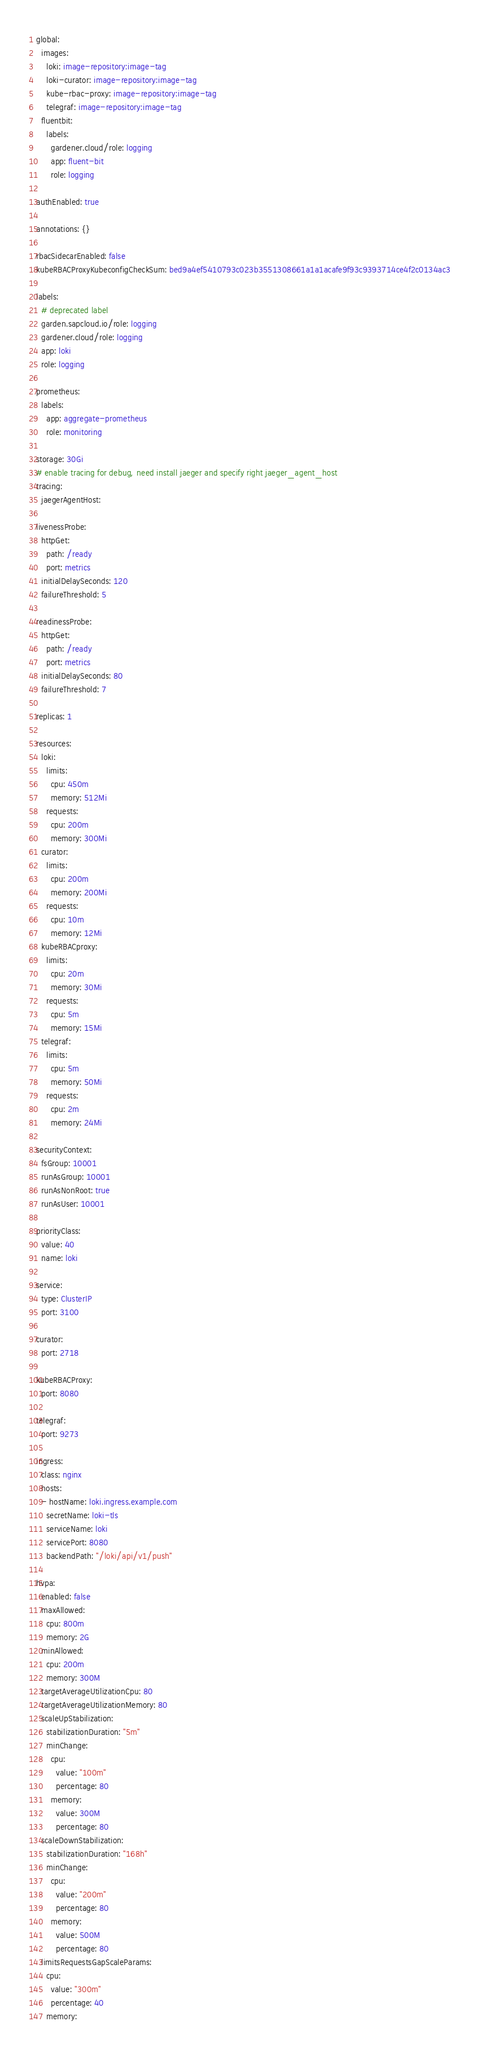Convert code to text. <code><loc_0><loc_0><loc_500><loc_500><_YAML_>global:
  images:
    loki: image-repository:image-tag
    loki-curator: image-repository:image-tag
    kube-rbac-proxy: image-repository:image-tag
    telegraf: image-repository:image-tag
  fluentbit:
    labels:
      gardener.cloud/role: logging
      app: fluent-bit
      role: logging

authEnabled: true

annotations: {}

rbacSidecarEnabled: false
kubeRBACProxyKubeconfigCheckSum: bed9a4ef5410793c023b3551308661a1a1acafe9f93c9393714ce4f2c0134ac3

labels:
  # deprecated label
  garden.sapcloud.io/role: logging
  gardener.cloud/role: logging
  app: loki
  role: logging

prometheus:
  labels:
    app: aggregate-prometheus
    role: monitoring

storage: 30Gi
# enable tracing for debug, need install jaeger and specify right jaeger_agent_host
tracing:
  jaegerAgentHost:

livenessProbe:
  httpGet:
    path: /ready
    port: metrics
  initialDelaySeconds: 120
  failureThreshold: 5

readinessProbe:
  httpGet:
    path: /ready
    port: metrics
  initialDelaySeconds: 80
  failureThreshold: 7

replicas: 1

resources:
  loki:
    limits:
      cpu: 450m
      memory: 512Mi
    requests:
      cpu: 200m
      memory: 300Mi
  curator:
    limits:
      cpu: 200m
      memory: 200Mi
    requests:
      cpu: 10m
      memory: 12Mi
  kubeRBACproxy:
    limits:
      cpu: 20m
      memory: 30Mi
    requests:
      cpu: 5m
      memory: 15Mi 
  telegraf:
    limits:
      cpu: 5m
      memory: 50Mi
    requests:
      cpu: 2m
      memory: 24Mi

securityContext:
  fsGroup: 10001
  runAsGroup: 10001
  runAsNonRoot: true
  runAsUser: 10001

priorityClass:
  value: 40
  name: loki

service:
  type: ClusterIP
  port: 3100

curator:
  port: 2718

kubeRBACProxy:
  port: 8080

telegraf:
  port: 9273

ingress:
  class: nginx
  hosts: 
  - hostName: loki.ingress.example.com 
    secretName: loki-tls
    serviceName: loki
    servicePort: 8080
    backendPath: "/loki/api/v1/push"

hvpa:
  enabled: false
  maxAllowed:
    cpu: 800m
    memory: 2G
  minAllowed:
    cpu: 200m
    memory: 300M
  targetAverageUtilizationCpu: 80
  targetAverageUtilizationMemory: 80
  scaleUpStabilization:
    stabilizationDuration: "5m"
    minChange:
      cpu:
        value: "100m"
        percentage: 80
      memory:
        value: 300M
        percentage: 80
  scaleDownStabilization:
    stabilizationDuration: "168h"
    minChange:
      cpu:
        value: "200m"
        percentage: 80
      memory:
        value: 500M
        percentage: 80
  limitsRequestsGapScaleParams:
    cpu:
      value: "300m"
      percentage: 40
    memory:</code> 